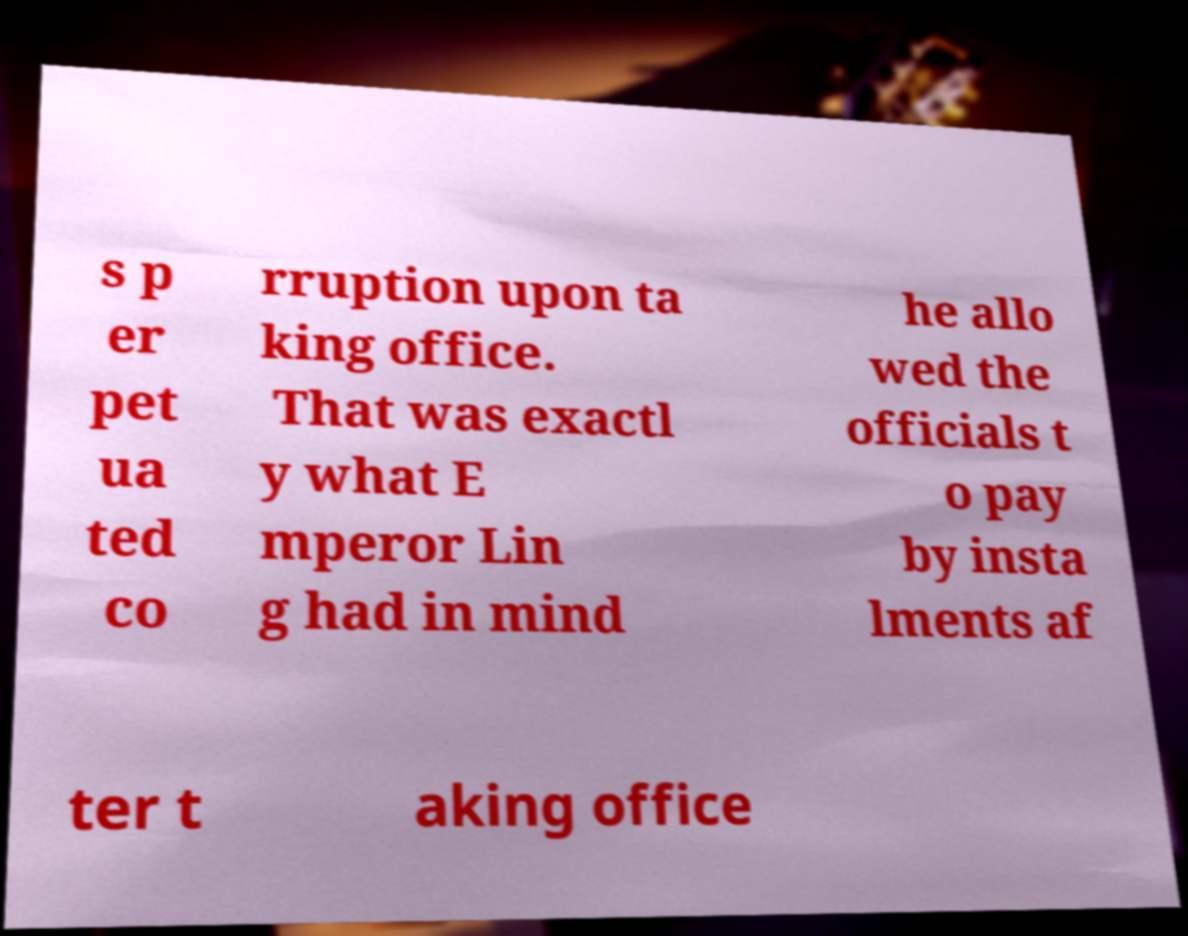For documentation purposes, I need the text within this image transcribed. Could you provide that? s p er pet ua ted co rruption upon ta king office. That was exactl y what E mperor Lin g had in mind he allo wed the officials t o pay by insta lments af ter t aking office 